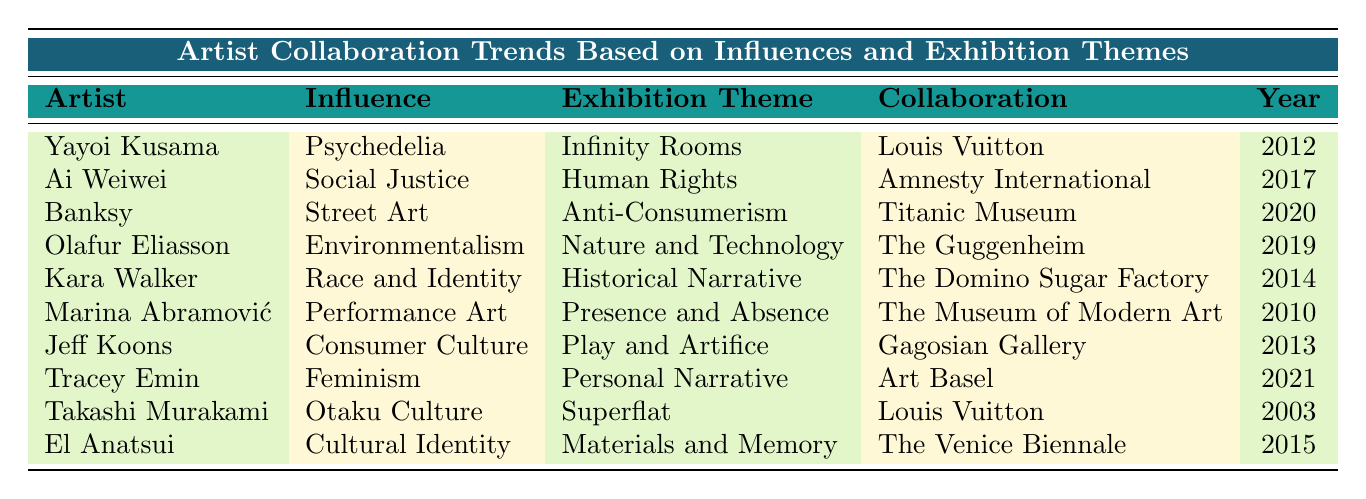What is the influence of Ai Weiwei? The table directly states that Ai Weiwei's influence is "Social Justice."
Answer: Social Justice Which artist collaborated with the Titanic Museum? The table indicates that Banksy collaborated with the Titanic Museum.
Answer: Banksy How many artists collaborated with Louis Vuitton? By counting the entries in the table, it can be found that Yayoi Kusama and Takashi Murakami both collaborated with Louis Vuitton, yielding a total of 2 artists.
Answer: 2 What was the exhibition theme for Tracey Emin? The table shows that Tracey Emin's exhibition theme is "Personal Narrative."
Answer: Personal Narrative In which year did Marina Abramović collaborate with The Museum of Modern Art? The table specifies that Marina Abramović collaborated with The Museum of Modern Art in the year 2010.
Answer: 2010 List all the influences represented in the table. The table lists multiple influences including Psychedelia, Social Justice, Street Art, Environmentalism, Race and Identity, Performance Art, Consumer Culture, Feminism, Otaku Culture, and Cultural Identity, totaling 10 distinct influences.
Answer: 10 distinct influences Which exhibition theme appears most frequently in collaborations? Reviewing the table, each exhibition theme appears only once, indicating that there is no repetition in themes across the collaborations.
Answer: No repeated themes Is there any artist whose collaboration occurred in the year 2019? The table confirms that Olafur Eliasson collaborated in the year 2019, thus the answer is yes.
Answer: Yes What is the collaboration of the artist inspired by Feminism? The table indicates that Tracey Emin, inspired by Feminism, collaborated with Art Basel.
Answer: Art Basel Identify the artist with the earliest collaboration year from the table. By examining the years listed, Takashi Murakami's collaboration in 2003 is the earliest year.
Answer: Takashi Murakami Which artist’s influence is related to Environmentalism and what is their collaboration? The table states that Olafur Eliasson's influence is Environmentalism and their collaboration is with The Guggenheim.
Answer: Olafur Eliasson, The Guggenheim 